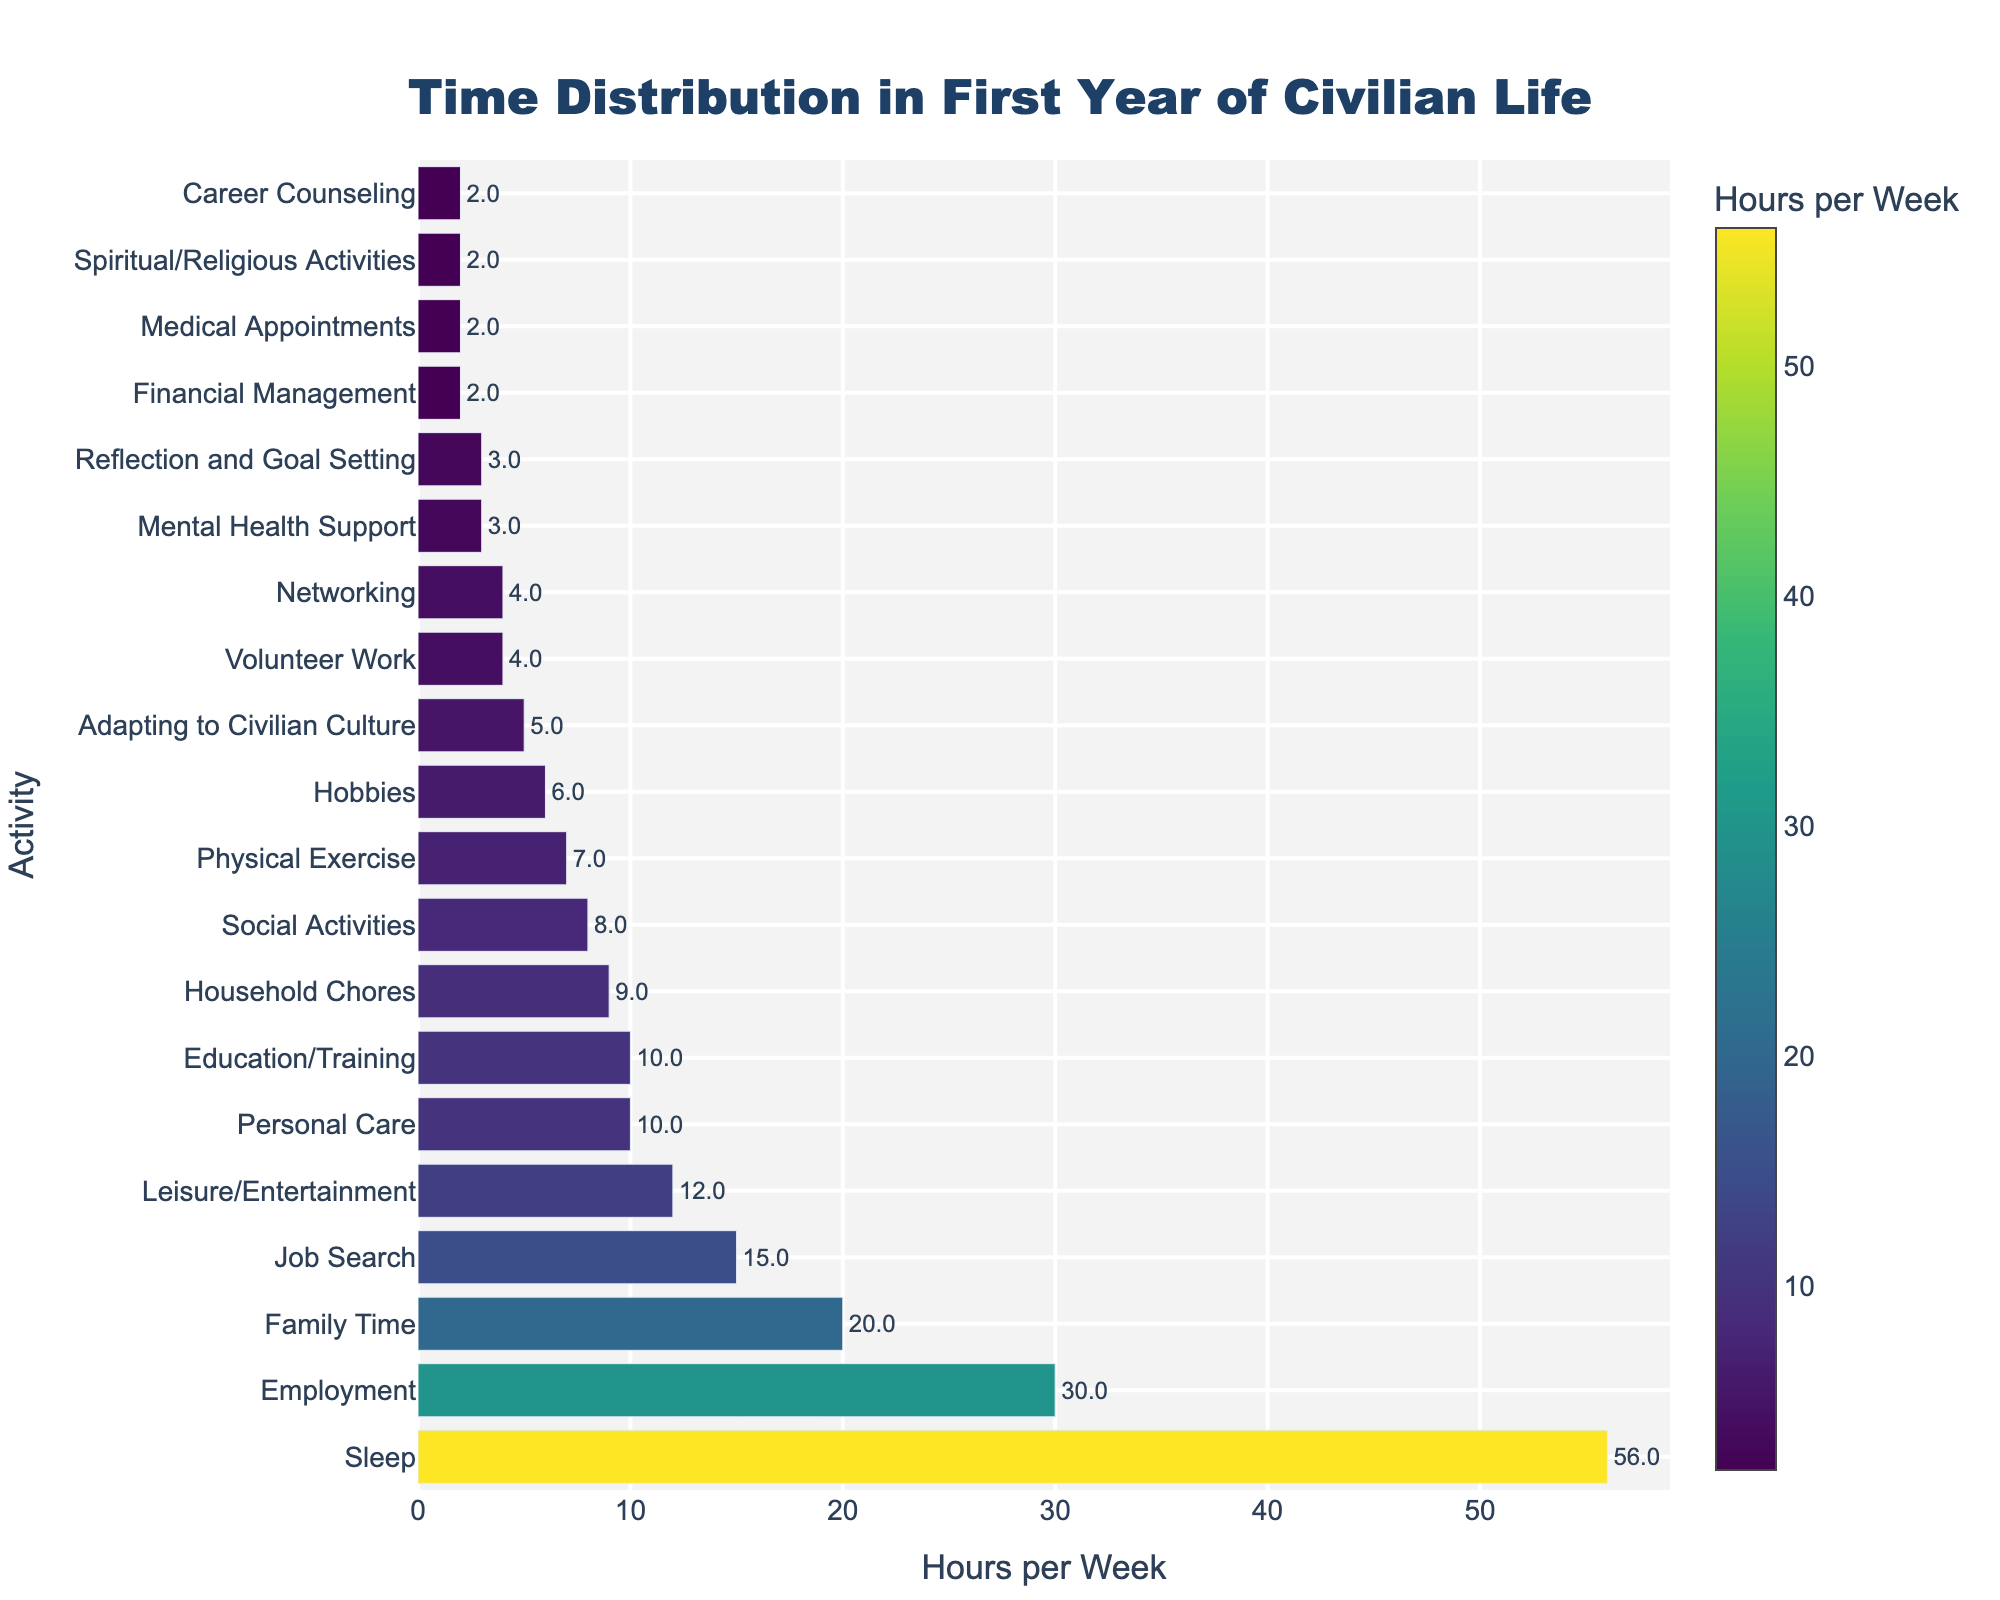What activity has the highest number of hours per week? The bar representing "Sleep" is the longest and reaches 56 hours per week, indicating that it has the highest number of hours.
Answer: Sleep Which activities are spent on less than 5 hours per week? The bars for "Financial Management", "Medical Appointments", "Spiritual/Religious Activities", "Career Counseling", "Reflection and Goal Setting", "Networking", "Volunteer Work", and "Mental Health Support" are all shorter than the 5-hour mark.
Answer: Financial Management, Medical Appointments, Spiritual/Religious Activities, Career Counseling, Reflection and Goal Setting, Networking, Volunteer Work, Mental Health Support What's the total time spent on job search and employment? The "Job Search" bar shows 15 hours and the "Employment" bar shows 30 hours. By adding these, we get a total of 15 + 30 = 45 hours per week.
Answer: 45 Which activities are allocated exactly 10 hours per week? The bars for "Education/Training" and "Personal Care" both reach the 10-hour mark, indicating that these two activities are each allocated 10 hours per week.
Answer: Education/Training, Personal Care Which activity has more time, "Family Time" or "Leisure/Entertainment"? By comparing the lengths of the bars, "Family Time" is longer at 20 hours per week, and "Leisure/Entertainment" is at 12 hours per week. Thus, "Family Time" has more time allocated.
Answer: Family Time How much more time is spent on social activities compared to volunteer work? "Social Activities" are allocated 8 hours per week, while "Volunteer Work" is allocated 4 hours. The difference is 8 - 4 = 4 hours more.
Answer: 4 Which activity uses approximately half the time of "Employment"? "Employment" is 30 hours per week, so half of that is 30 / 2 = 15 hours. The bar closest to 15 hours is "Job Search", which is at exactly 15 hours per week.
Answer: Job Search What is the combined time spent on "Mental Health Support" and "Physical Exercise"? "Mental Health Support" shows 3 hours and "Physical Exercise" shows 7 hours. Adding these together: 3 + 7 = 10 hours per week.
Answer: 10 Is more time spent on personal care or on hobbies? By comparing the bars for "Personal Care" and "Hobbies", "Personal Care" is at 10 hours per week, and "Hobbies" is at 6 hours per week. Therefore, more time is spent on "Personal Care".
Answer: Personal Care What is the average time spent on "Medical Appointments", "Financial Management", "Career Counseling", and "Spiritual/Religious Activities"? Adding up the hours: 2 (Medical Appointments) + 2 (Financial Management) + 2 (Career Counseling) + 2 (Spiritual/Religious Activities) equals 8 hours. Dividing by 4 activities: 8 / 4 = 2 hours per week on average.
Answer: 2 